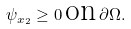<formula> <loc_0><loc_0><loc_500><loc_500>\psi _ { x _ { 2 } } \geq 0 \, \text {on} \, \partial \Omega .</formula> 